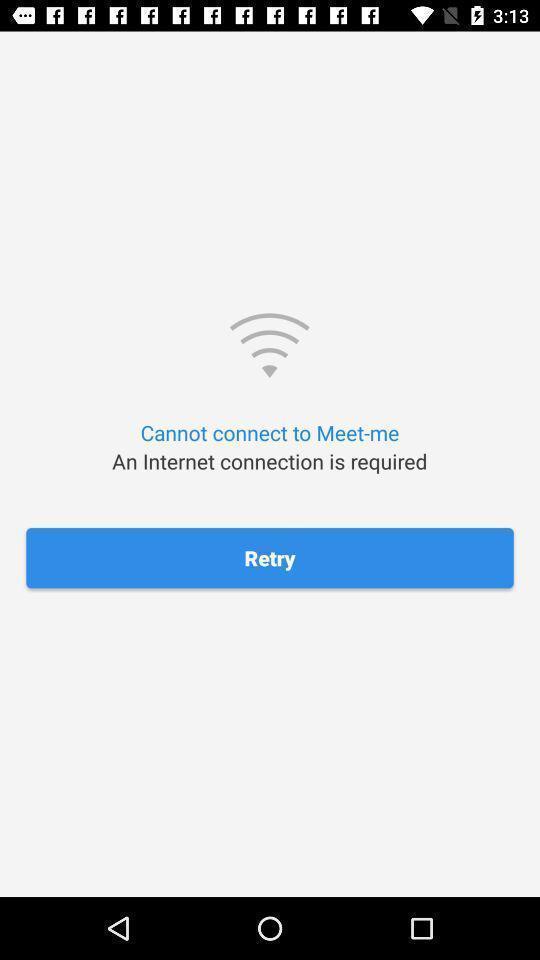Give me a summary of this screen capture. Page shows the retry option to connect on social app. 